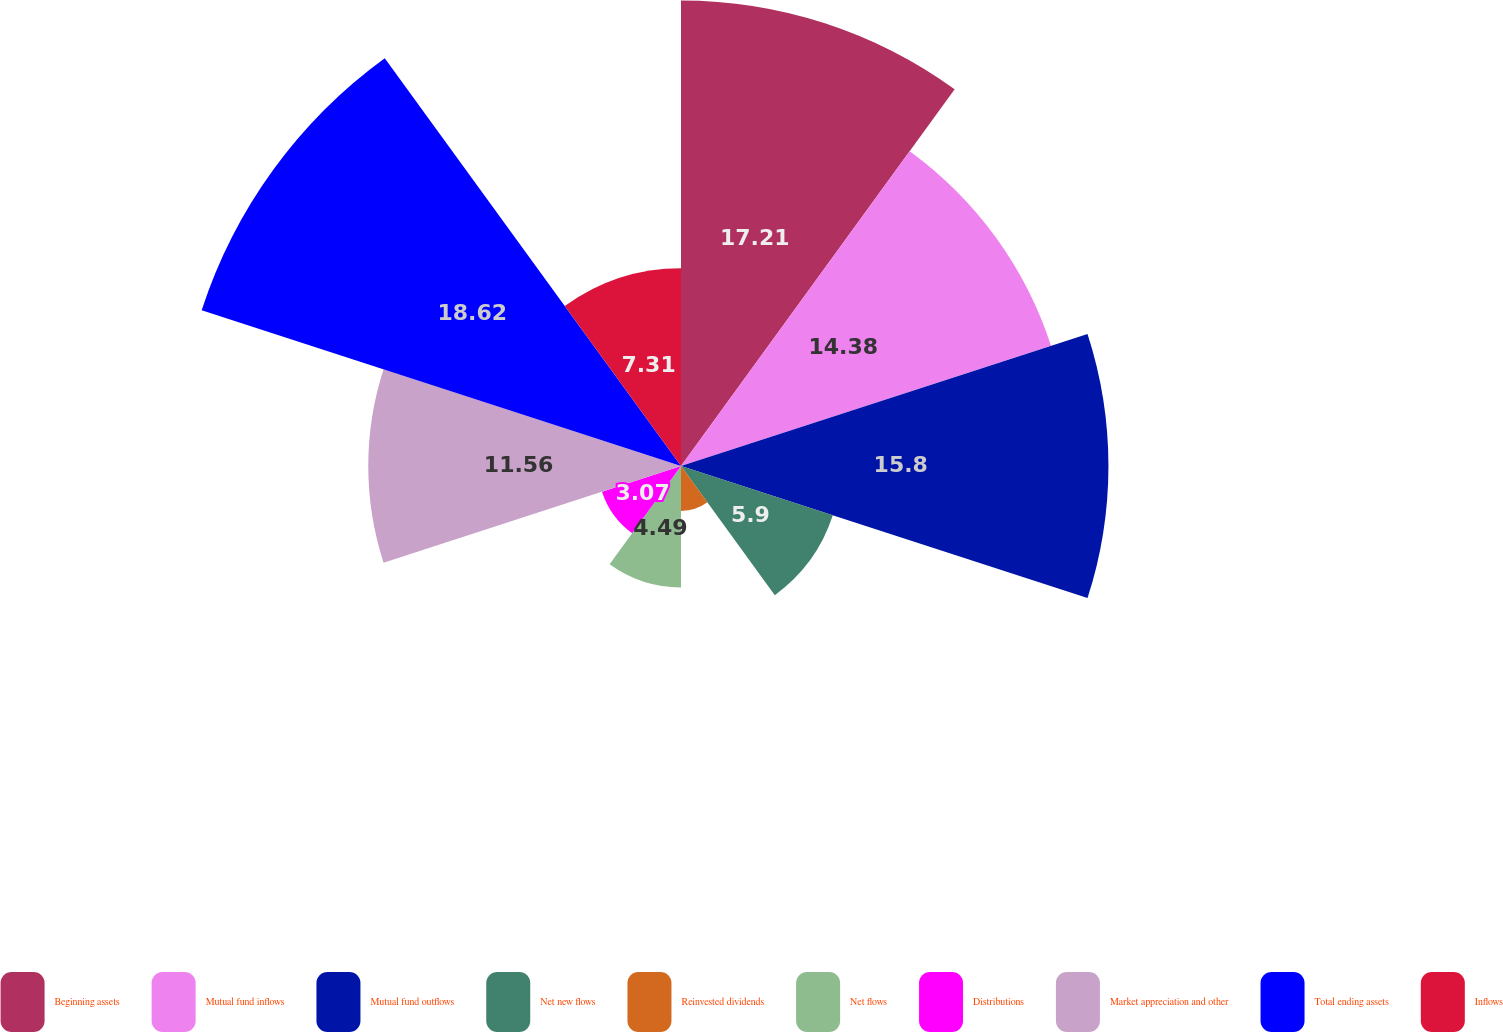Convert chart to OTSL. <chart><loc_0><loc_0><loc_500><loc_500><pie_chart><fcel>Beginning assets<fcel>Mutual fund inflows<fcel>Mutual fund outflows<fcel>Net new flows<fcel>Reinvested dividends<fcel>Net flows<fcel>Distributions<fcel>Market appreciation and other<fcel>Total ending assets<fcel>Inflows<nl><fcel>17.21%<fcel>14.38%<fcel>15.8%<fcel>5.9%<fcel>1.66%<fcel>4.49%<fcel>3.07%<fcel>11.56%<fcel>18.63%<fcel>7.31%<nl></chart> 